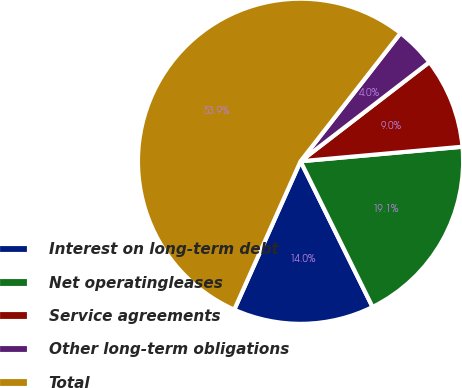Convert chart to OTSL. <chart><loc_0><loc_0><loc_500><loc_500><pie_chart><fcel>Interest on long-term debt<fcel>Net operatingleases<fcel>Service agreements<fcel>Other long-term obligations<fcel>Total<nl><fcel>13.99%<fcel>19.12%<fcel>9.01%<fcel>4.02%<fcel>53.86%<nl></chart> 